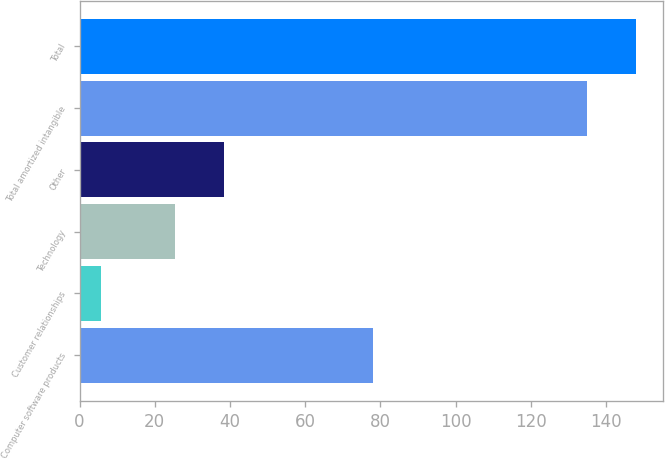Convert chart to OTSL. <chart><loc_0><loc_0><loc_500><loc_500><bar_chart><fcel>Computer software products<fcel>Customer relationships<fcel>Technology<fcel>Other<fcel>Total amortized intangible<fcel>Total<nl><fcel>77.9<fcel>5.6<fcel>25.4<fcel>38.33<fcel>134.9<fcel>147.83<nl></chart> 